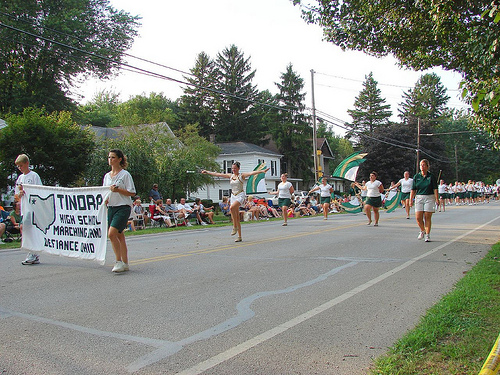<image>
Is the woman on the street? No. The woman is not positioned on the street. They may be near each other, but the woman is not supported by or resting on top of the street. Is the boy behind the lady? No. The boy is not behind the lady. From this viewpoint, the boy appears to be positioned elsewhere in the scene. 